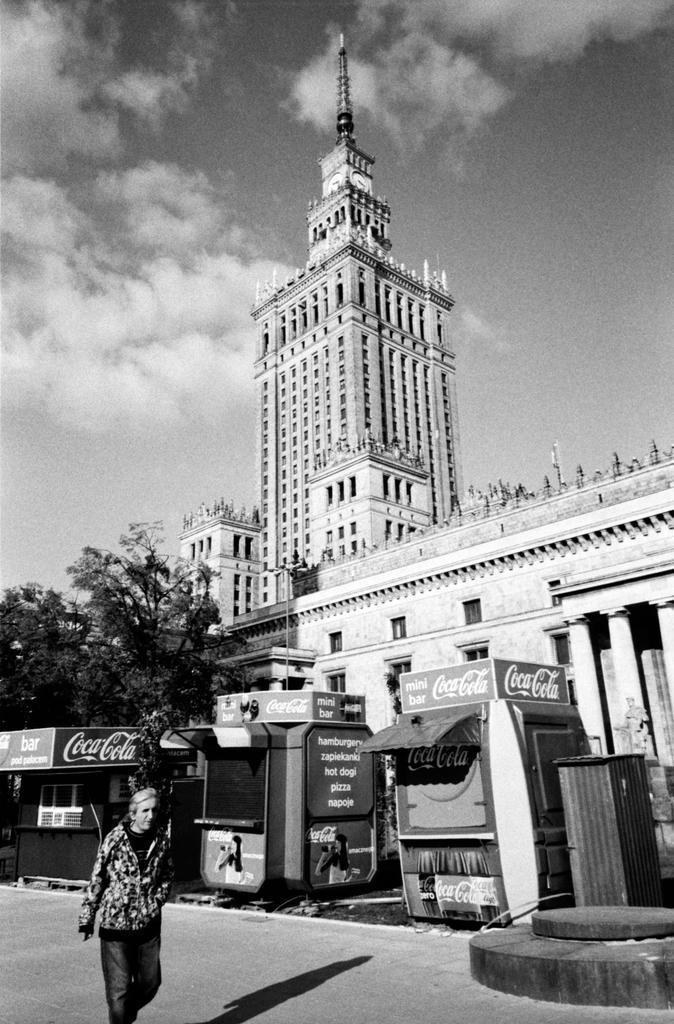In one or two sentences, can you explain what this image depicts? At the bottom of this image, there is a person walking on the road. On the right side, there are shops, which are having the boards. In the background, there are buildings, which are having windows, there are trees and there are clouds in the sky. 